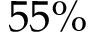Convert formula to latex. <formula><loc_0><loc_0><loc_500><loc_500>5 5 \%</formula> 